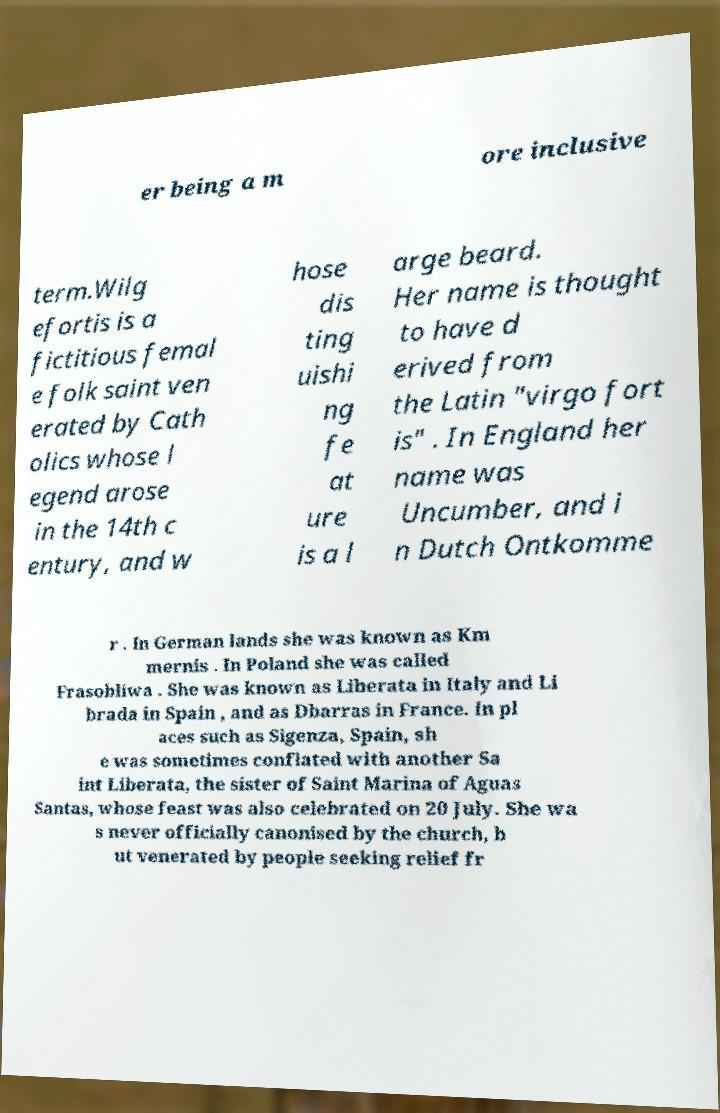There's text embedded in this image that I need extracted. Can you transcribe it verbatim? er being a m ore inclusive term.Wilg efortis is a fictitious femal e folk saint ven erated by Cath olics whose l egend arose in the 14th c entury, and w hose dis ting uishi ng fe at ure is a l arge beard. Her name is thought to have d erived from the Latin "virgo fort is" . In England her name was Uncumber, and i n Dutch Ontkomme r . In German lands she was known as Km mernis . In Poland she was called Frasobliwa . She was known as Liberata in Italy and Li brada in Spain , and as Dbarras in France. In pl aces such as Sigenza, Spain, sh e was sometimes conflated with another Sa int Liberata, the sister of Saint Marina of Aguas Santas, whose feast was also celebrated on 20 July. She wa s never officially canonised by the church, b ut venerated by people seeking relief fr 